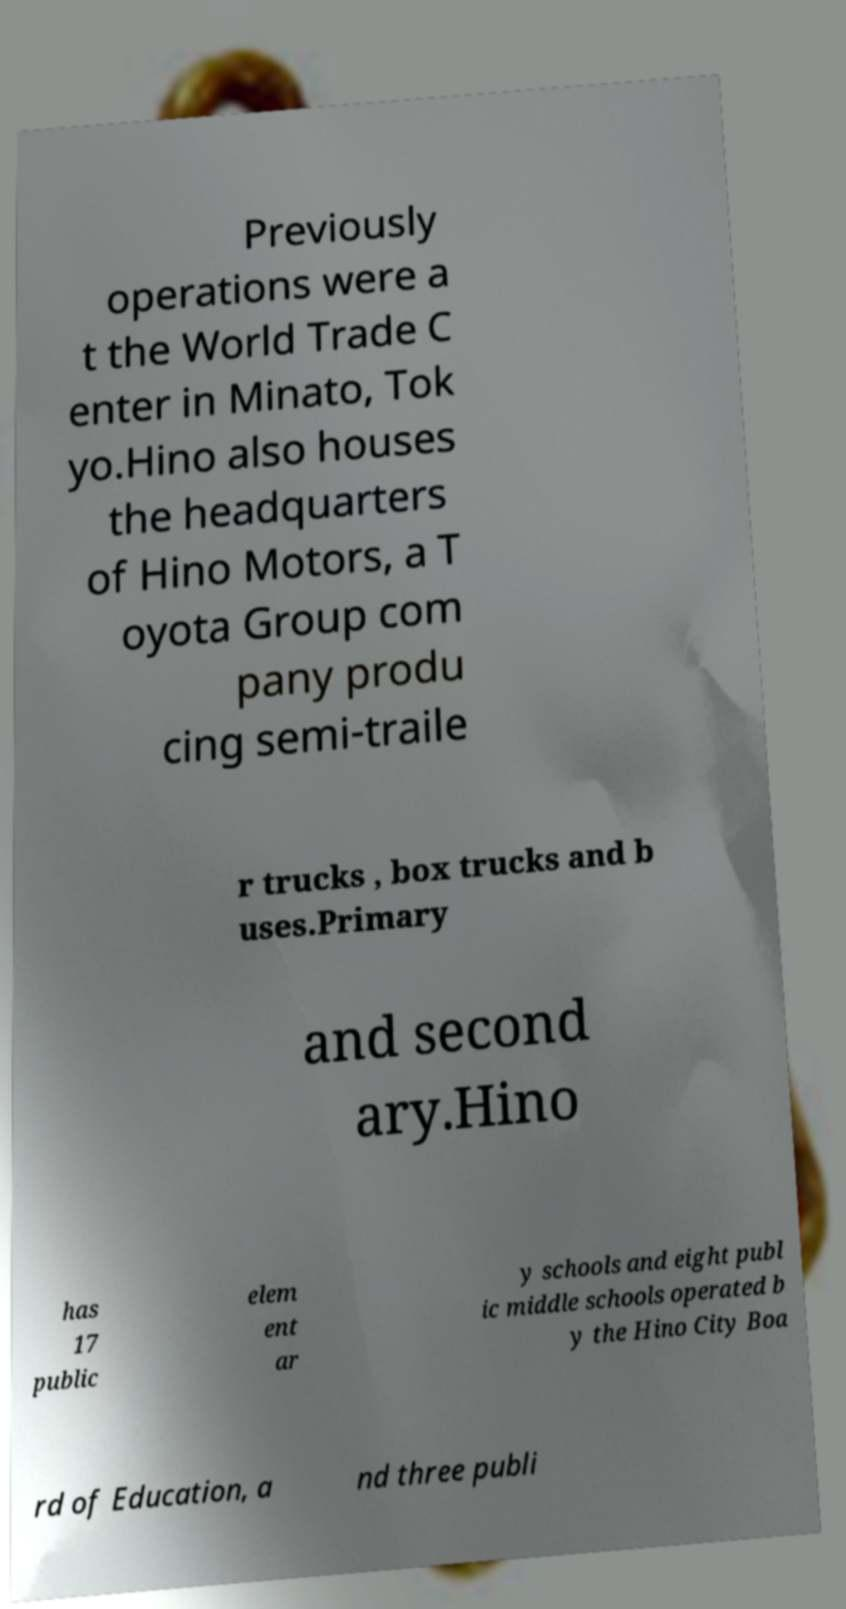I need the written content from this picture converted into text. Can you do that? Previously operations were a t the World Trade C enter in Minato, Tok yo.Hino also houses the headquarters of Hino Motors, a T oyota Group com pany produ cing semi-traile r trucks , box trucks and b uses.Primary and second ary.Hino has 17 public elem ent ar y schools and eight publ ic middle schools operated b y the Hino City Boa rd of Education, a nd three publi 